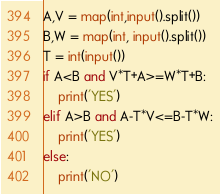Convert code to text. <code><loc_0><loc_0><loc_500><loc_500><_Python_>A,V = map(int,input().split())
B,W = map(int, input().split())
T = int(input())
if A<B and V*T+A>=W*T+B:
    print('YES')
elif A>B and A-T*V<=B-T*W:
    print('YES')
else:
    print('NO')</code> 